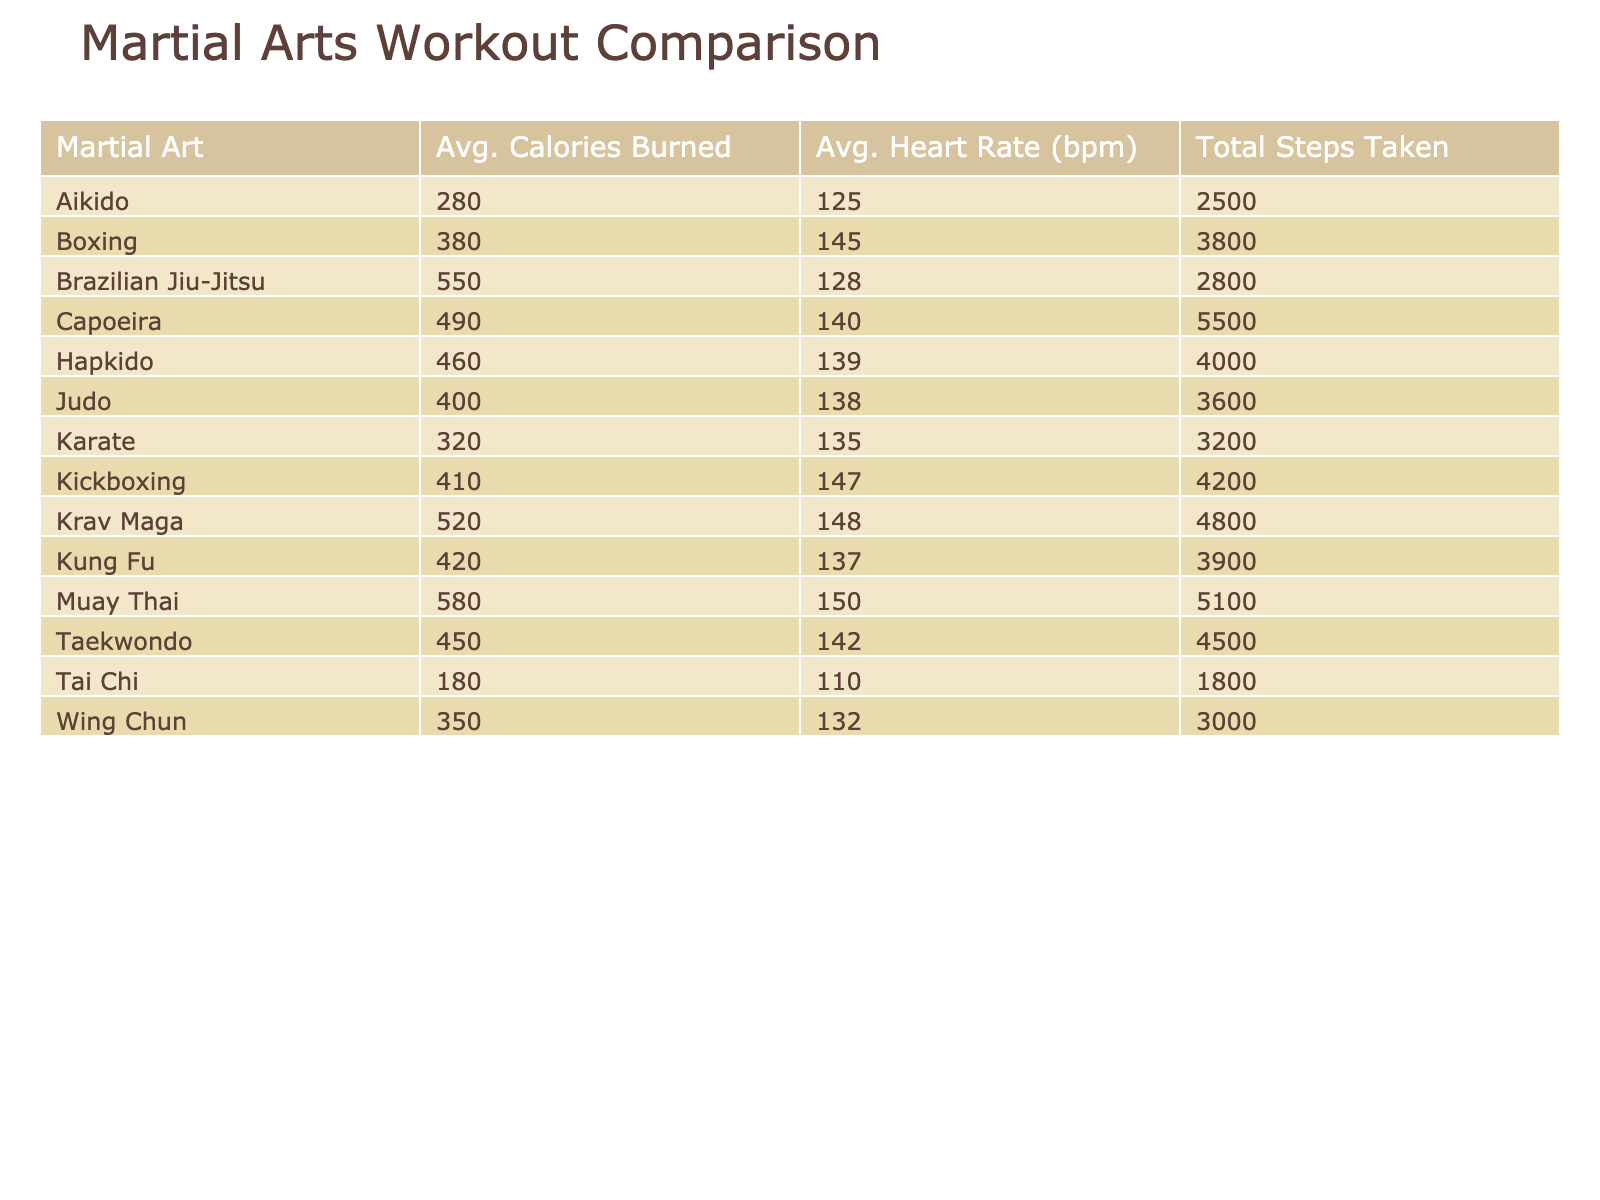What is the average calories burned for Karate? Referring to the table, the average calories burned for Karate is stated under the "Avg. Calories Burned" column next to Karate. The value listed is 320 calories.
Answer: 320 Which martial art has the highest average heart rate? In the table, comparing the values in the "Avg. Heart Rate (bpm)" column, Muay Thai has the highest average heart rate with a value of 150 bpm.
Answer: 150 How many total steps are taken in Brazilian Jiu-Jitsu workouts? Looking at the "Total Steps Taken" column for Brazilian Jiu-Jitsu, the total number of steps reported is 2800 steps.
Answer: 2800 Which martial art had the lowest average calories burned? When examining the "Avg. Calories Burned" column, Aikido has the lowest average, which is 280 calories.
Answer: 280 Is the average heart rate for Tai Chi higher than that for Judo? By comparing the values in the "Avg. Heart Rate (bpm)" column, Tai Chi has an average heart rate of 110 bpm, and Judo has 138 bpm, so Tai Chi's average heart rate is not higher than Judo’s.
Answer: No What is the difference in average calories burned between Kickboxing and Hapkido? Kickboxing has an average calories burned value of 410 calories, while Hapkido has 460 calories. The difference is calculated as 460 - 410 = 50 calories.
Answer: 50 Which martial arts workouts have a high impact level and burn more than 500 calories? From the table, Muay Thai (580 calories) and Krav Maga (520 calories) both have a high impact level and exceed 500 calories burned.
Answer: Muay Thai and Krav Maga If you combine the total steps taken from Karate and Capoeira, what is the total? The total steps taken for Karate is 3200 and for Capoeira is 5500. Adding these values gives 3200 + 5500 = 8700 steps in total.
Answer: 8700 Does any martial art listed have an average heart rate of exactly 140 bpm? In the "Avg. Heart Rate (bpm)" column, the only martial art with an average heart rate of exactly 140 bpm is Capoeira.
Answer: Yes 